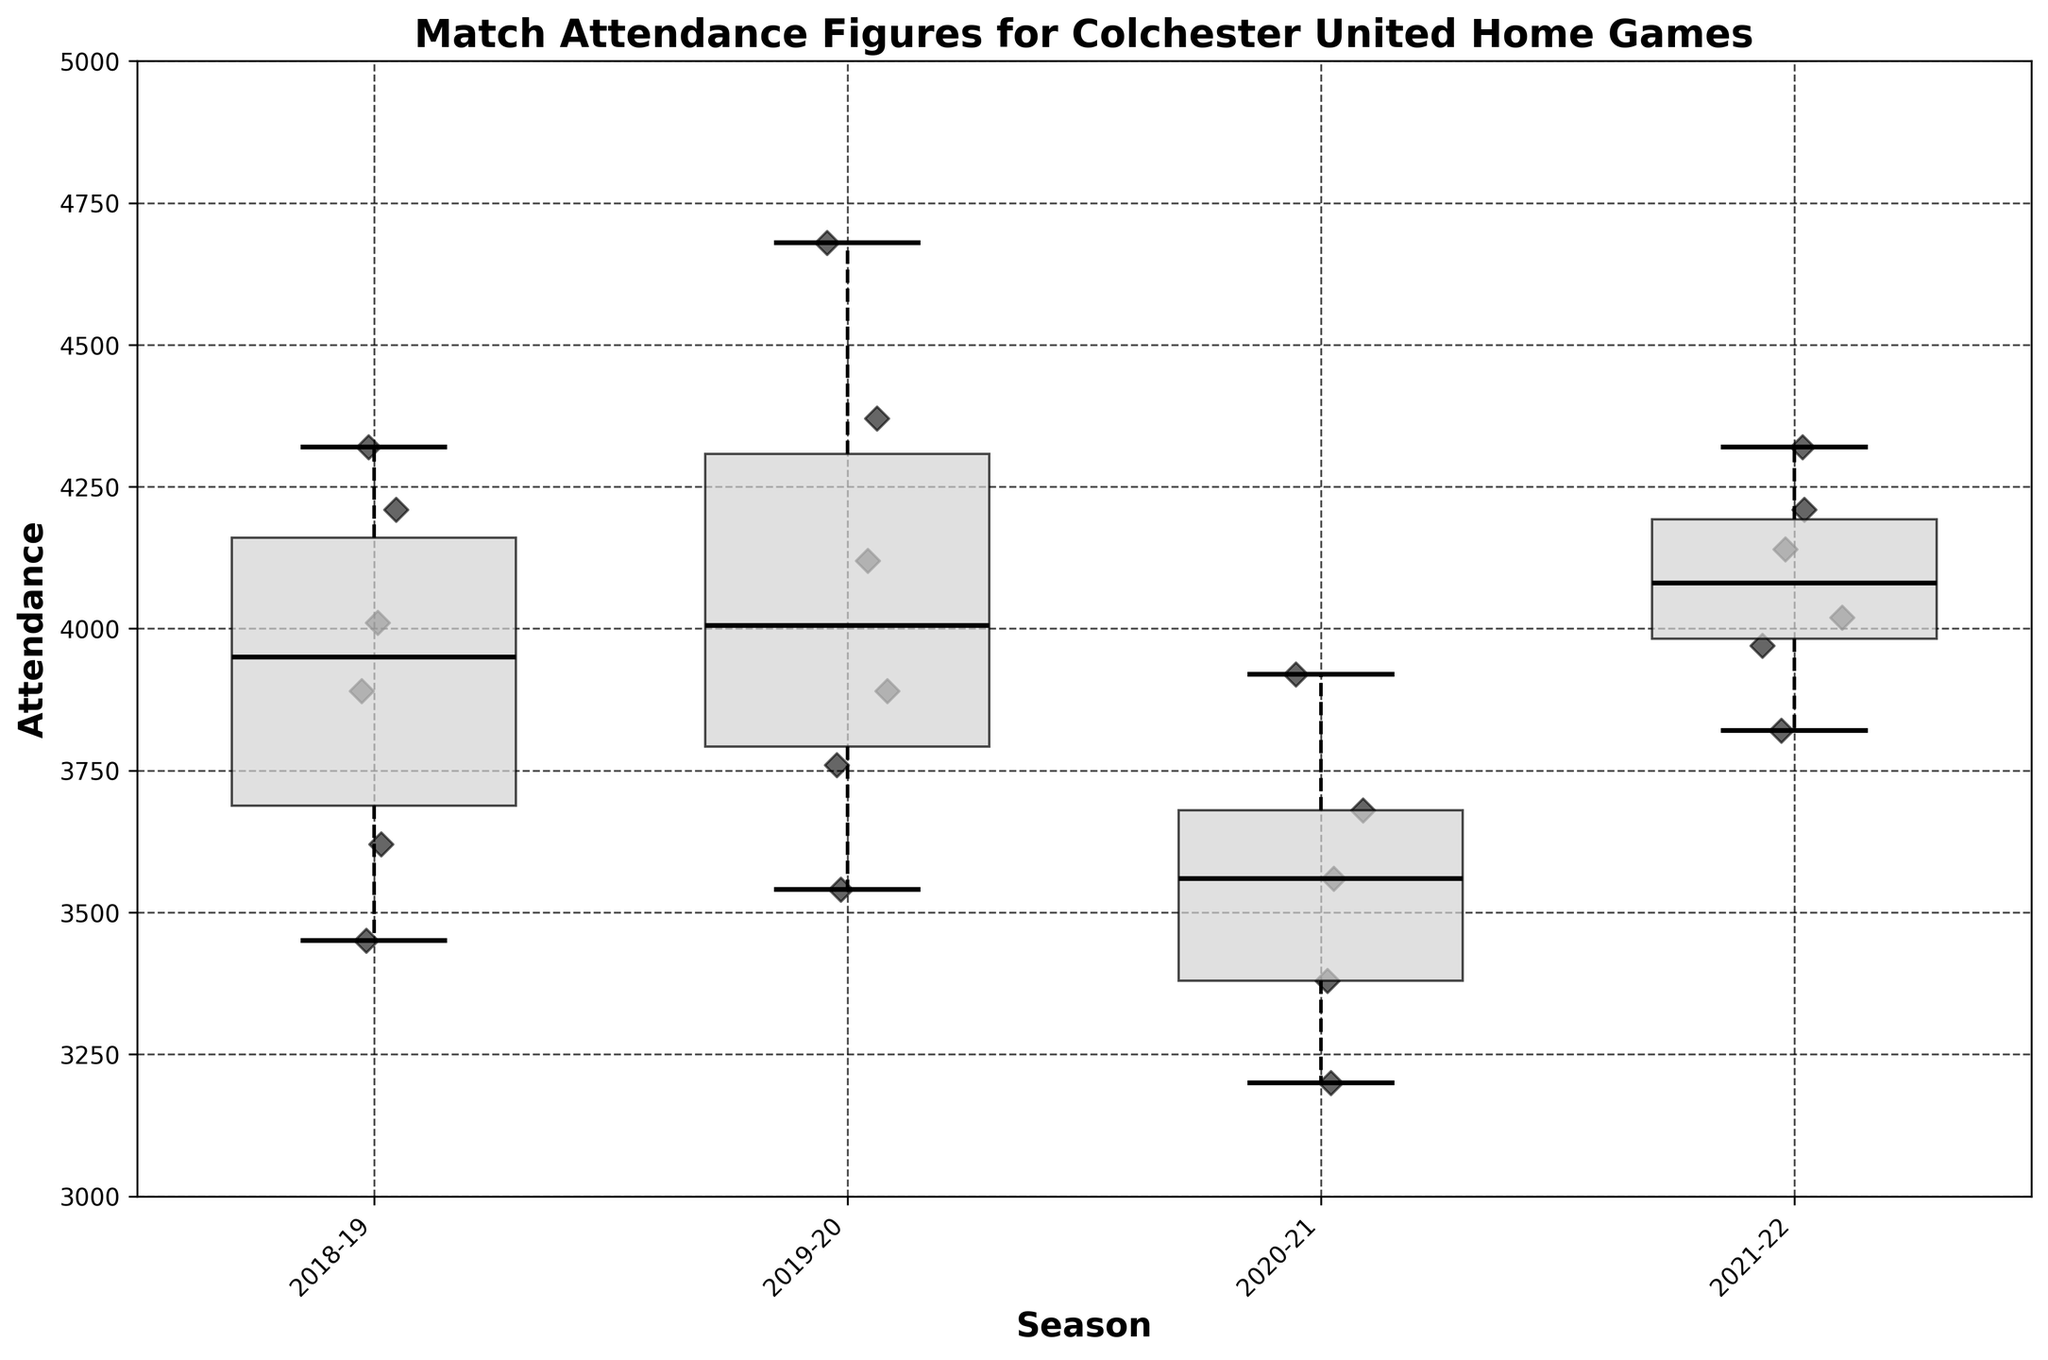What's the title of the chart? The title of the chart is located at the top and provides an overview of the contents. It reads "Match Attendance Figures for Colchester United Home Games".
Answer: Match Attendance Figures for Colchester United Home Games How many seasons are represented in the chart? The x-axis labels represent different seasons, providing the needed information. By counting the unique labels, you can see there are four seasons represented.
Answer: Four What is the range of attendance values shown on the y-axis? The y-axis displays the range for attendance figures. By inspecting the axis, you can see it ranges from 3000 to 5000 attendees.
Answer: 3000 to 5000 Which season appears to have the highest median attendance? Inspecting the median lines (bold lines across the boxes) of each season's box plot helps identify the season with the highest median. The 2019-20 season has the highest median attendance.
Answer: 2019-20 Which season has the most dispersed attendance values? To determine the season with the most dispersion, look at the spread of the whiskers and fliers in each box plot. The 2018-19 season's box plot shows the greatest spread.
Answer: 2018-19 What is the minimum attendance recorded in the 2020-21 season? The lower whisker of the 2020-21 season's box plot points to the minimum attendance value. The minimum attendance recorded is 3200.
Answer: 3200 Compare the interquartile range (IQR) of the 2019-20 and 2021-22 seasons' attendance. Which season has a larger IQR? The height difference between the top and bottom of the box (excluding whiskers) represents the IQR. By comparing box heights, the 2019-20 season has a larger IQR compared to the 2021-22 season.
Answer: 2019-20 How does the scatter of data points add to understanding the attendance variability? Scatter points offer a more detailed view of each individual game's attendance, showing outliers and clustering that might not be apparent from the box plot alone. This helps to identify games with notably high or low attendances.
Answer: Details individual variability How many scatter points are there in the plot for the 2018-19 season? Count the individual scatter points visible within the range of the 2018-19 season's box plot. There are six points visible.
Answer: Six What does the position of the median line tell you about the skewness of attendance figures for the 2021-22 season? The median line's position within the box provides a sense of skewness. In the 2021-22 season, the median is closer to the bottom of the box, suggesting a right or positive skew in the attendance figures.
Answer: Right skew 